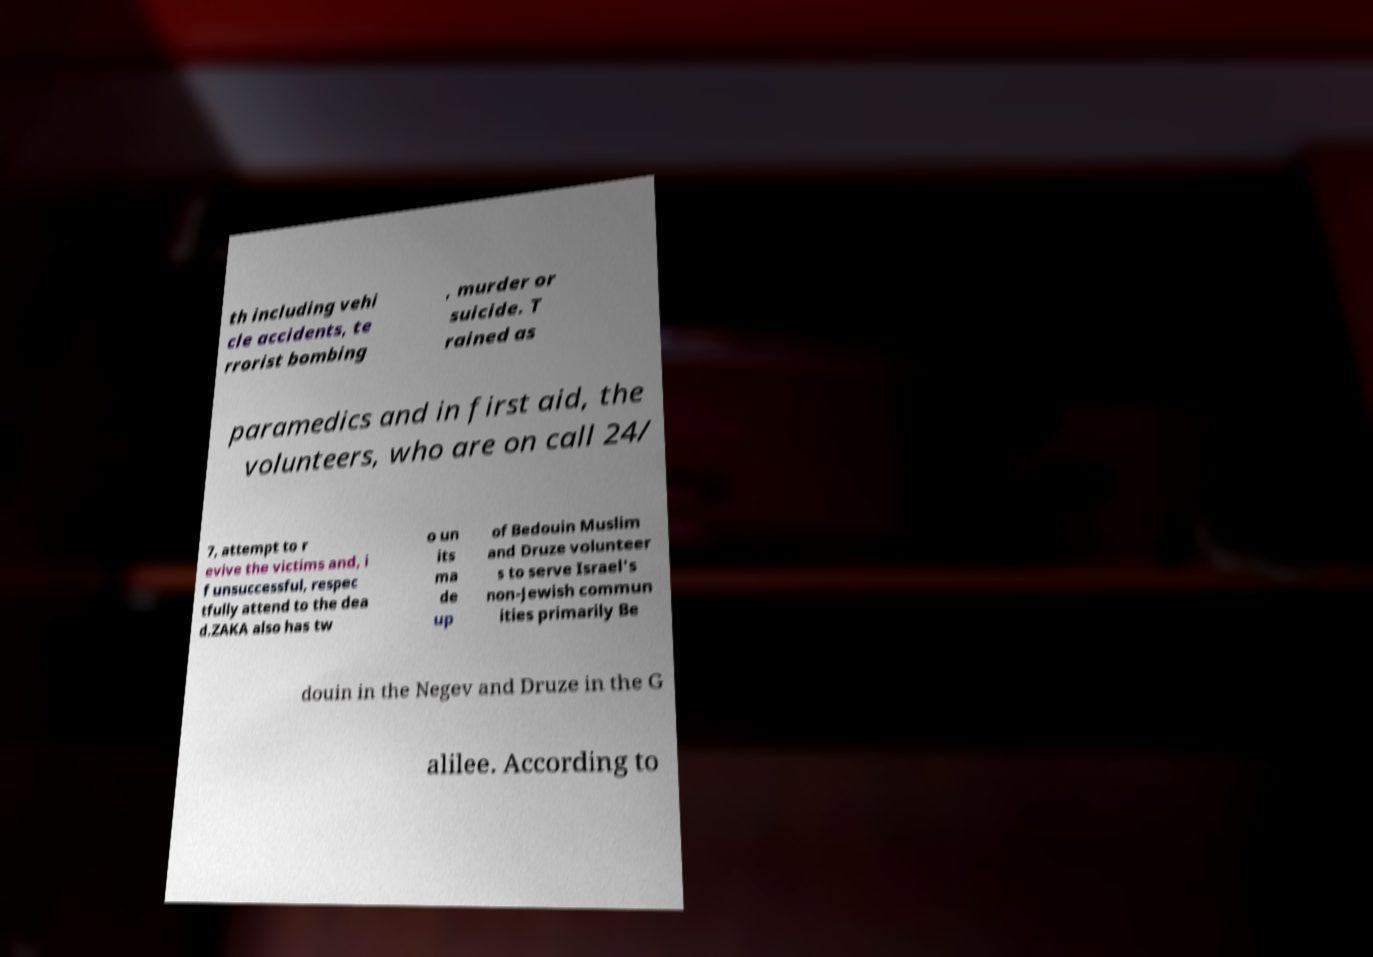There's text embedded in this image that I need extracted. Can you transcribe it verbatim? th including vehi cle accidents, te rrorist bombing , murder or suicide. T rained as paramedics and in first aid, the volunteers, who are on call 24/ 7, attempt to r evive the victims and, i f unsuccessful, respec tfully attend to the dea d.ZAKA also has tw o un its ma de up of Bedouin Muslim and Druze volunteer s to serve Israel's non-Jewish commun ities primarily Be douin in the Negev and Druze in the G alilee. According to 